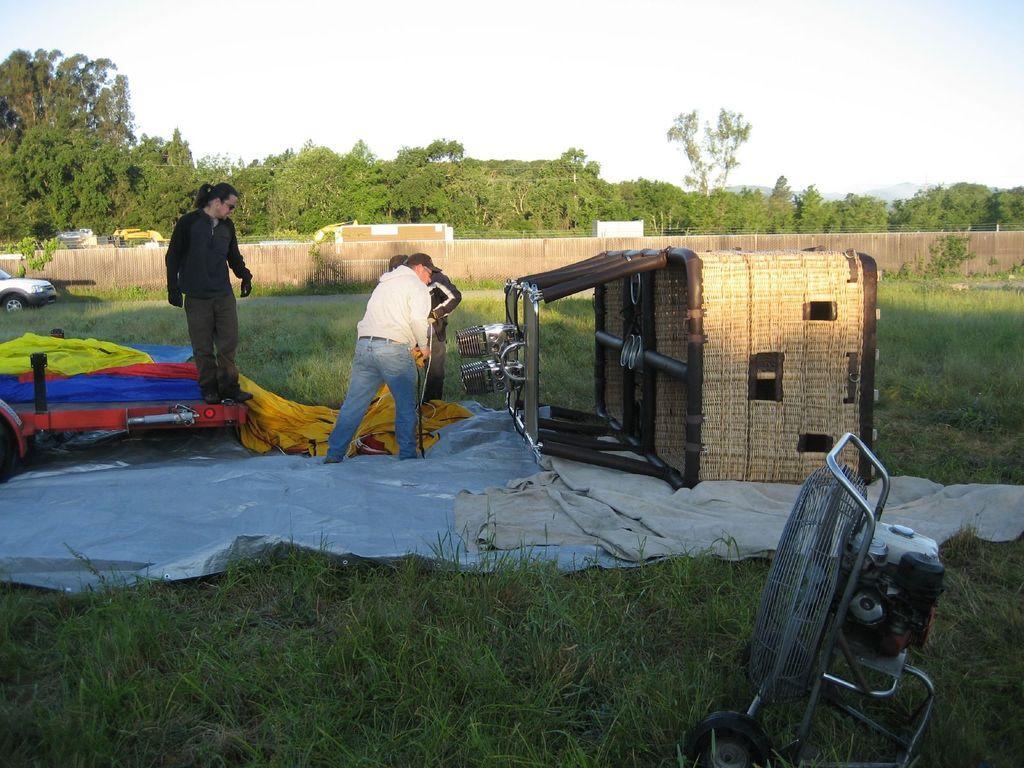How would you summarize this image in a sentence or two? In this image I can see a person wearing white and blue dress and another person wearing black and brown dress are standing on sheets which are blue, yellow and orange in color. I can see a huge wooden basket and a balloon cloth. I can see some grass and in the background I can see the wall, few trees and the sky. 